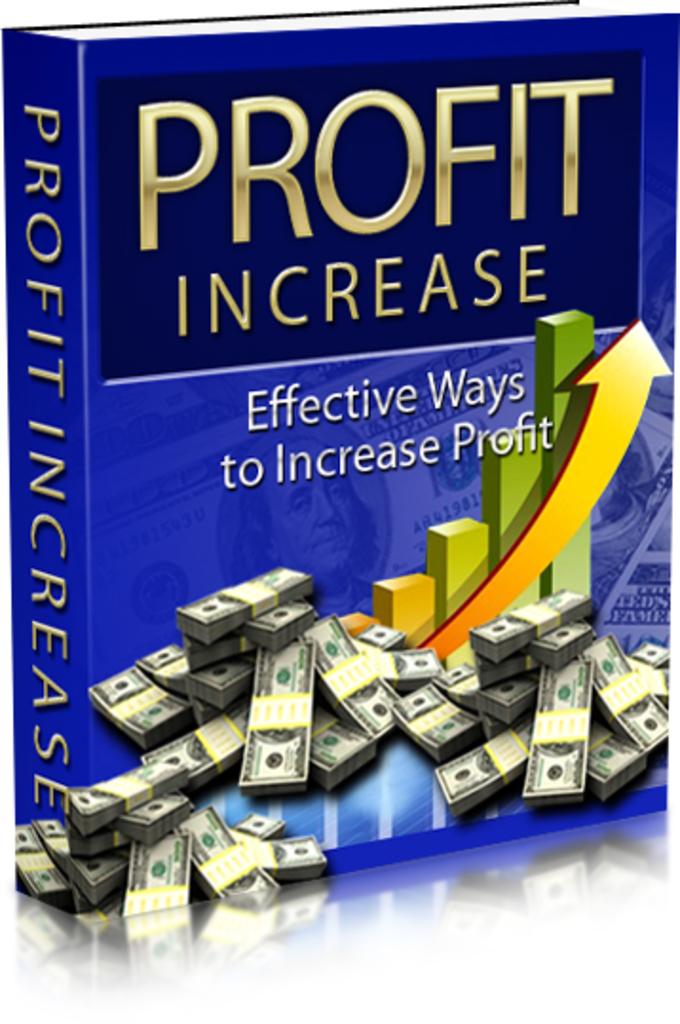What is this book designed to increase?
Make the answer very short. Profit. Is this book about effective or ineffective ways?
Make the answer very short. Effective. 